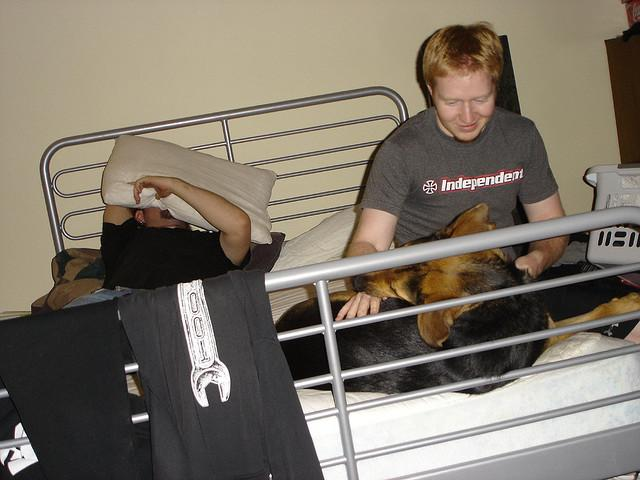What tool is printed on the shirt on the railing? Please explain your reasoning. wrench. That is what the tool is. 